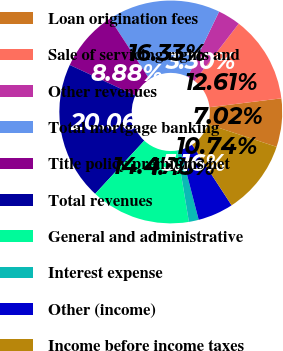Convert chart. <chart><loc_0><loc_0><loc_500><loc_500><pie_chart><fcel>Loan origination fees<fcel>Sale of servicing rights and<fcel>Other revenues<fcel>Total mortgage banking<fcel>Title policy premiums net<fcel>Total revenues<fcel>General and administrative<fcel>Interest expense<fcel>Other (income)<fcel>Income before income taxes<nl><fcel>7.02%<fcel>12.61%<fcel>3.3%<fcel>16.33%<fcel>8.88%<fcel>20.06%<fcel>14.47%<fcel>1.43%<fcel>5.16%<fcel>10.74%<nl></chart> 